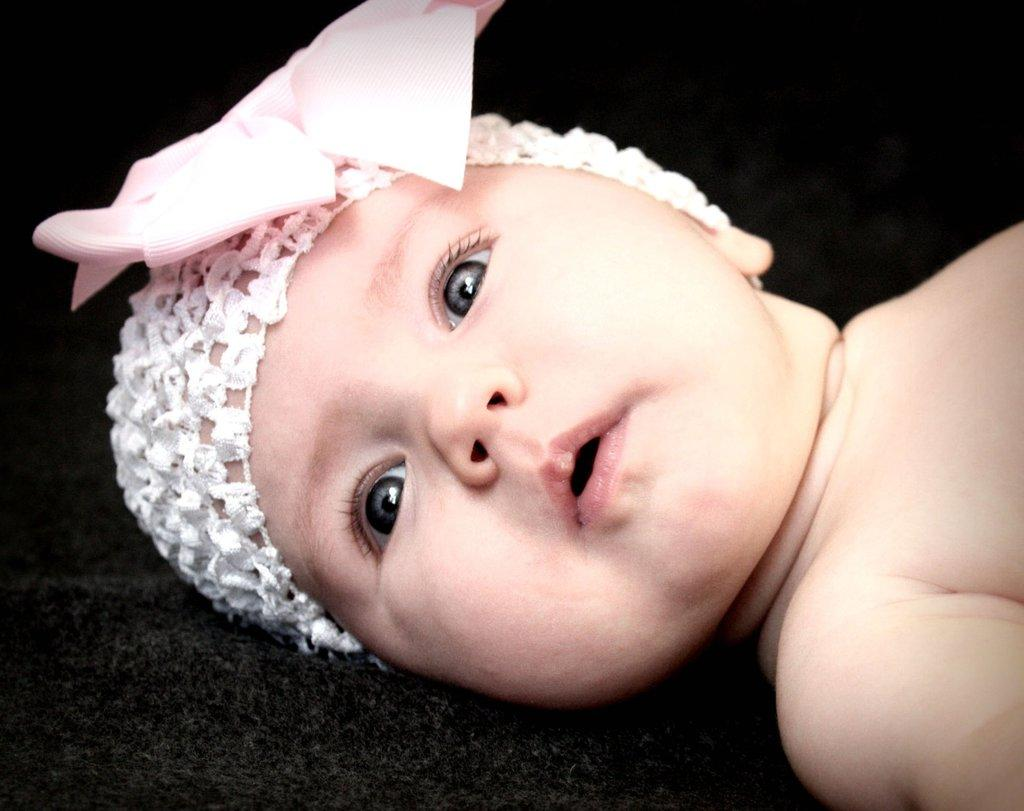What is the main subject of the image? There is a baby in the image. What is the baby's position in the image? The baby is lying down. What is the baby wearing on their head? The baby is wearing a white cap. What color is the background of the image? The background of the image is black. What type of house is visible in the background of the image? There is no house visible in the background of the image; the background is black. What part of the baby's brain can be seen in the image? The image does not show any part of the baby's brain; it only shows the baby lying down with a white cap. 